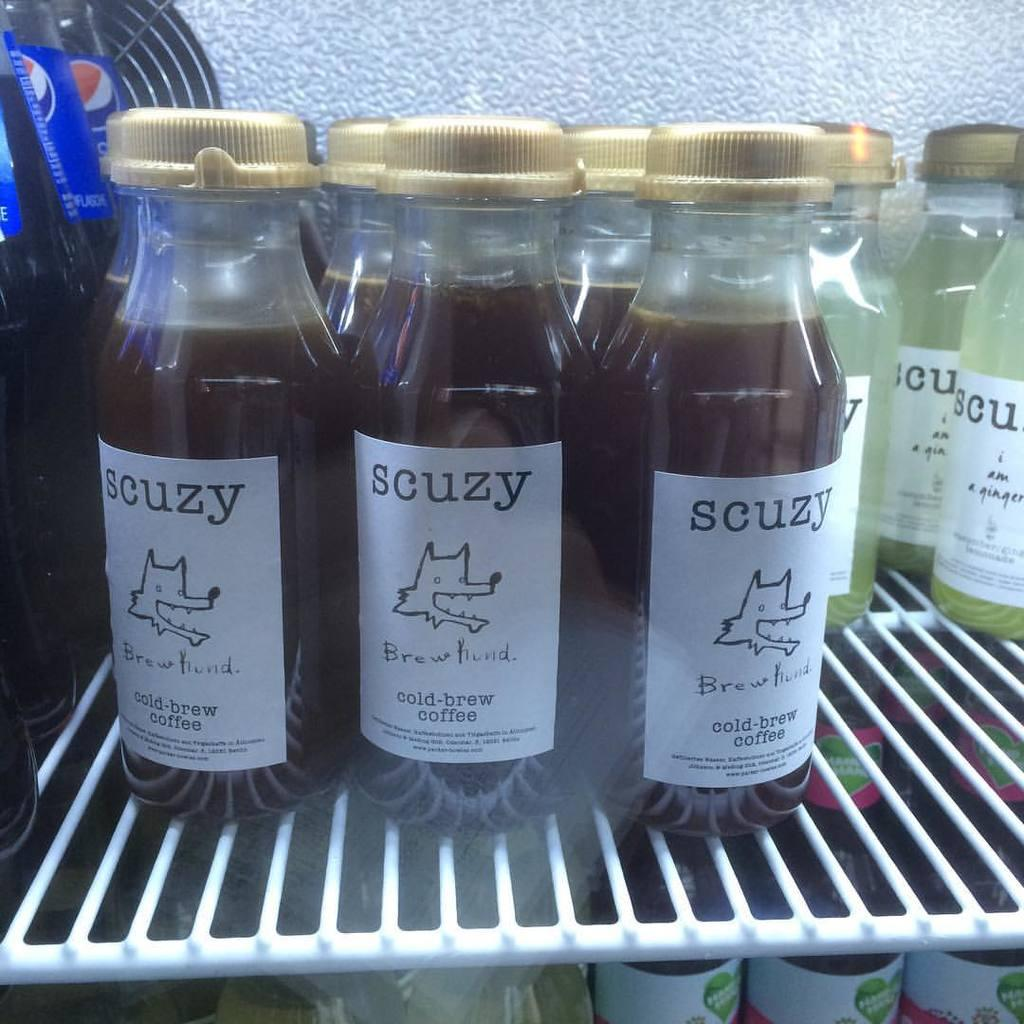<image>
Offer a succinct explanation of the picture presented. Several bottles of Scuzy cold-brew coffee are on a shelf next to some soda and other Scuzy brand drinks. 